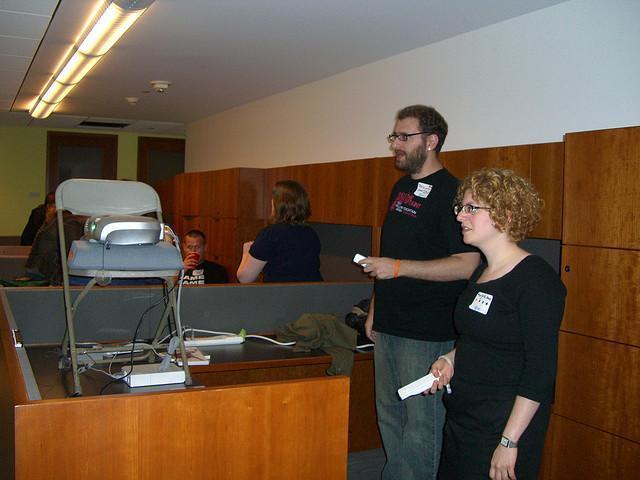How many people can be seen?
Give a very brief answer. 4. 